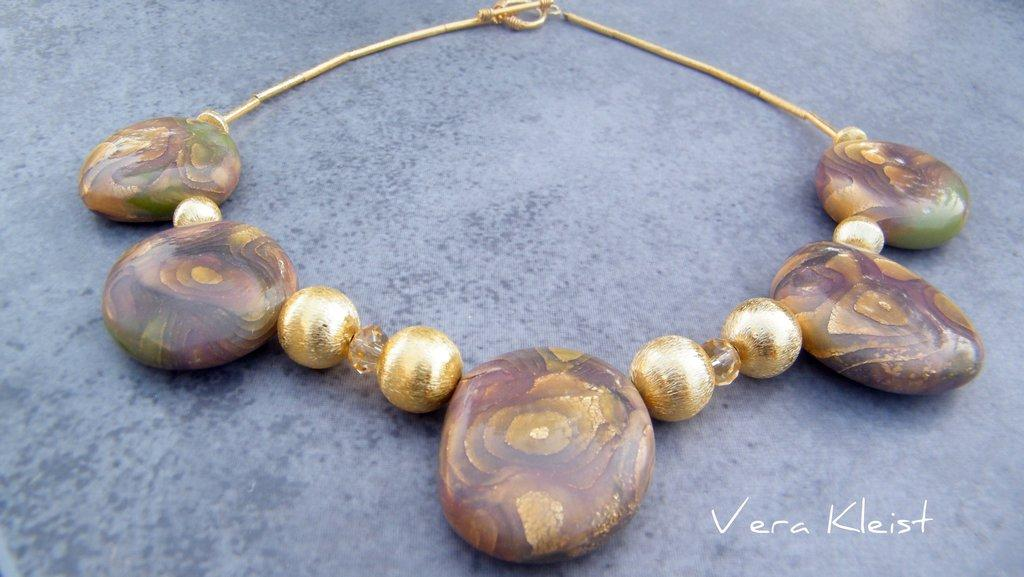What type of jewelry is present in the image? There is a necklace in the image. What materials are used in the necklace? The necklace contains marbles and stones. What is the color of the background in the image? The background color of the image is gray. How many stars can be seen in the image? There are no stars present in the image. What type of unit is used to measure the size of the marbles in the necklace? The size of the marbles in the necklace is not mentioned in the image, so it is not possible to determine the unit of measurement. 